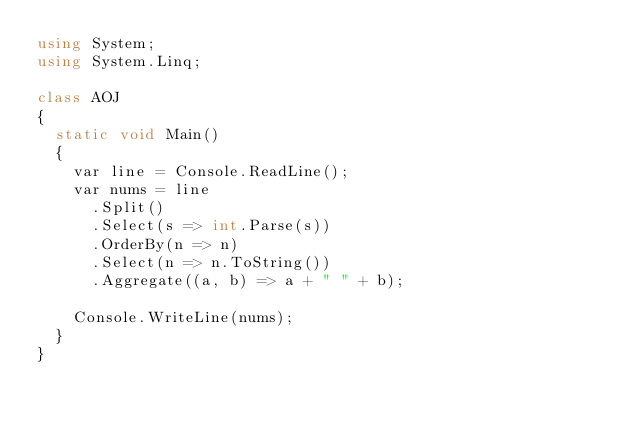Convert code to text. <code><loc_0><loc_0><loc_500><loc_500><_C#_>using System;
using System.Linq;

class AOJ
{
	static void Main()
	{
		var line = Console.ReadLine();
		var nums = line
			.Split()
			.Select(s => int.Parse(s))
			.OrderBy(n => n)
			.Select(n => n.ToString())
			.Aggregate((a, b) => a + " " + b);

		Console.WriteLine(nums);
	}
}</code> 